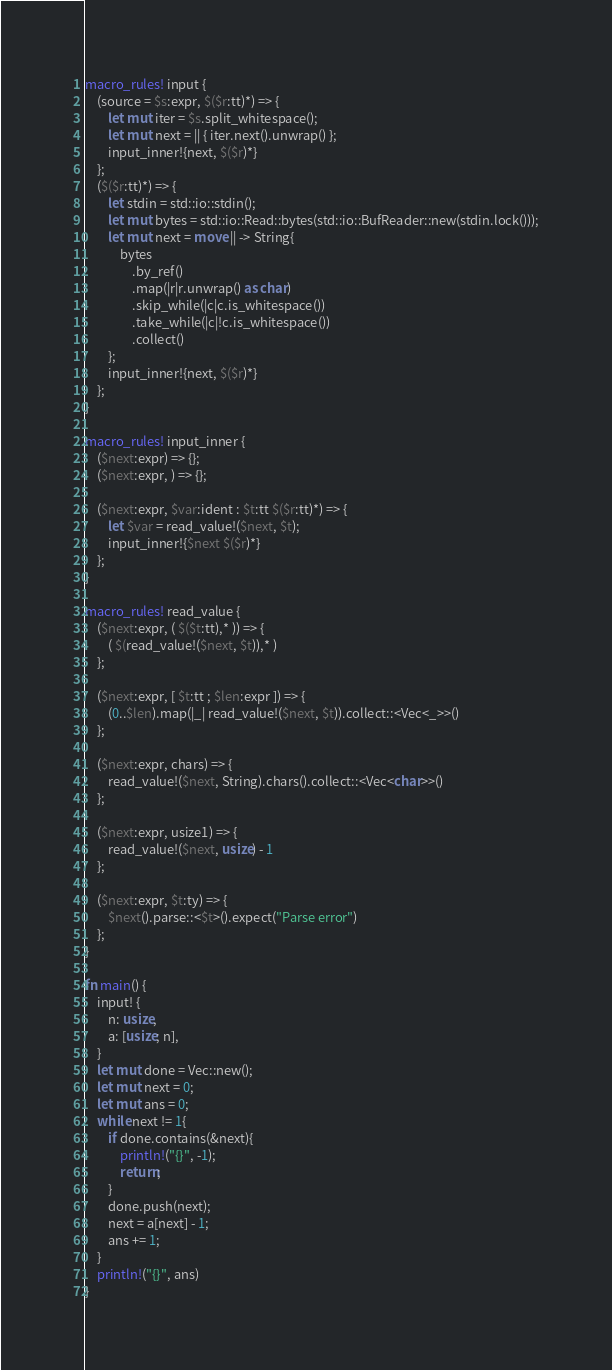Convert code to text. <code><loc_0><loc_0><loc_500><loc_500><_Rust_>macro_rules! input {
    (source = $s:expr, $($r:tt)*) => {
        let mut iter = $s.split_whitespace();
        let mut next = || { iter.next().unwrap() };
        input_inner!{next, $($r)*}
    };
    ($($r:tt)*) => {
        let stdin = std::io::stdin();
        let mut bytes = std::io::Read::bytes(std::io::BufReader::new(stdin.lock()));
        let mut next = move || -> String{
            bytes
                .by_ref()
                .map(|r|r.unwrap() as char)
                .skip_while(|c|c.is_whitespace())
                .take_while(|c|!c.is_whitespace())
                .collect()
        };
        input_inner!{next, $($r)*}
    };
}

macro_rules! input_inner {
    ($next:expr) => {};
    ($next:expr, ) => {};

    ($next:expr, $var:ident : $t:tt $($r:tt)*) => {
        let $var = read_value!($next, $t);
        input_inner!{$next $($r)*}
    };
}

macro_rules! read_value {
    ($next:expr, ( $($t:tt),* )) => {
        ( $(read_value!($next, $t)),* )
    };

    ($next:expr, [ $t:tt ; $len:expr ]) => {
        (0..$len).map(|_| read_value!($next, $t)).collect::<Vec<_>>()
    };

    ($next:expr, chars) => {
        read_value!($next, String).chars().collect::<Vec<char>>()
    };

    ($next:expr, usize1) => {
        read_value!($next, usize) - 1
    };

    ($next:expr, $t:ty) => {
        $next().parse::<$t>().expect("Parse error")
    };
}

fn main() {
    input! {
        n: usize,
        a: [usize; n],
    }
    let mut done = Vec::new();
    let mut next = 0;
    let mut ans = 0;
    while next != 1{
        if done.contains(&next){
            println!("{}", -1);
            return;
        }
        done.push(next);
        next = a[next] - 1;
        ans += 1;
    }
    println!("{}", ans)
}

</code> 